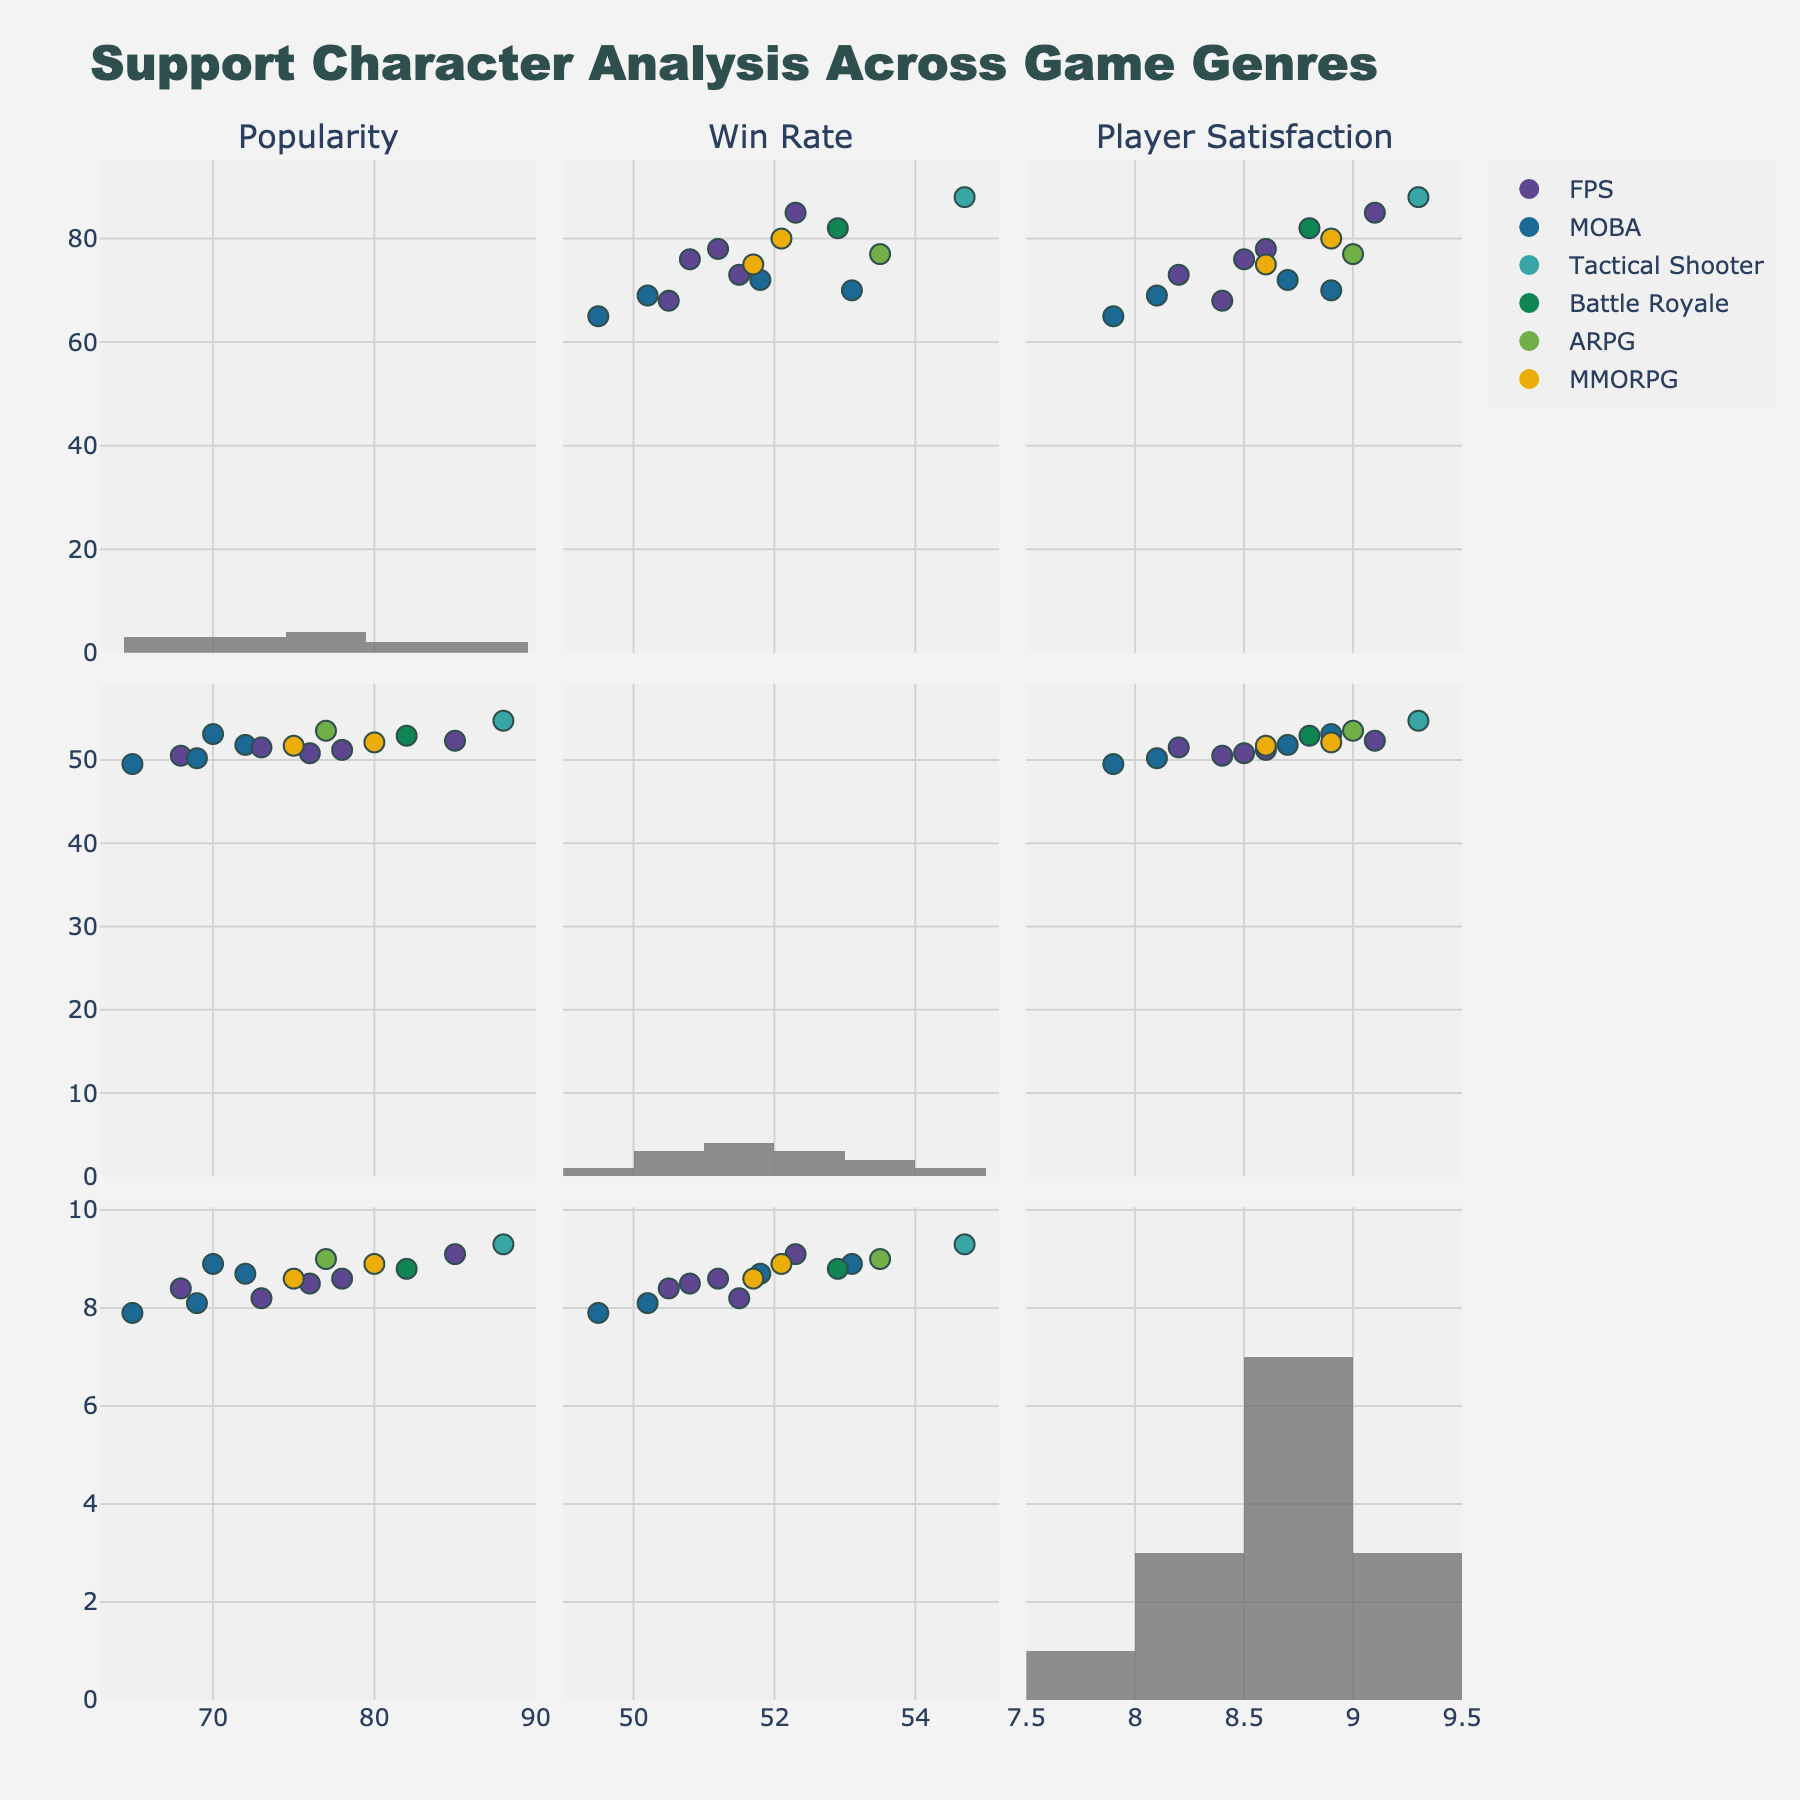what is the title of the figure? The title of the figure is displayed at the top, indicating a summary of what the visual represents. The exact title can be seen directly at the top of the subplot.
Answer: Voter Turnout by Age Group and Region (2016 vs 2020) What age group in the Northeast had the highest turnout percentage in 2020? In the subplot for the Northeast, looking at the data for the year 2020 and identifying the highest turnout percentage across different age groups.
Answer: 65+ How did the voter turnout percentage change for the 45-54 age group in the South between 2016 and 2020? Comparing the data points for the 45-54 age group in the South for the years 2016 and 2020 and calculating the difference.
Answer: Increased by 2.9% What was the voter turnout percentage for the 18-24 age group in the Midwest in 2020? Identifying the data point for the 18-24 age group in the Midwest in the subplot for the year 2020.
Answer: 54.1% Among the four regions, which had the lowest voter turnout in the 25-34 age group in 2016? Comparing the turnout percentages for the 25-34 age group across all four regions in 2016 and finding the lowest value.
Answer: South Which region saw the biggest increase in voter turnout percentage in the 35-44 age group from 2016 to 2020? Calculating the difference in voter turnout percentage from 2016 to 2020 for the 35-44 age group in each region and comparing the changes.
Answer: Midwest Did any age group in the West region decrease in voter turnout percentage from 2016 to 2020? Checking each age group's turnout percentage in the West region for both years to see if any group had a lower value in 2020 compared to 2016.
Answer: No What is the general trend of voter turnout percentages by age group across all regions from 2016 to 2020? Observing all subplots and identifying whether the turnout percentages generally increased, decreased, or remained the same for most age groups from 2016 to 2020.
Answer: Increased Which age group in the Midwest had the highest voter turnout percentage in 2016, and how does that compare to the West's highest age group in 2020? First, identifying the highest turnout percentage in the Midwest in 2016, then identifying the highest in the West in 2020, and comparing the two values.
Answer: 65+ Midwest 2016: 76.5%, 65+ West 2020: 78.1% What color is used to represent the 2020 data? Observing the scatter plot legend to determine which color corresponds to the data points for the year 2020.
Answer: Orange 